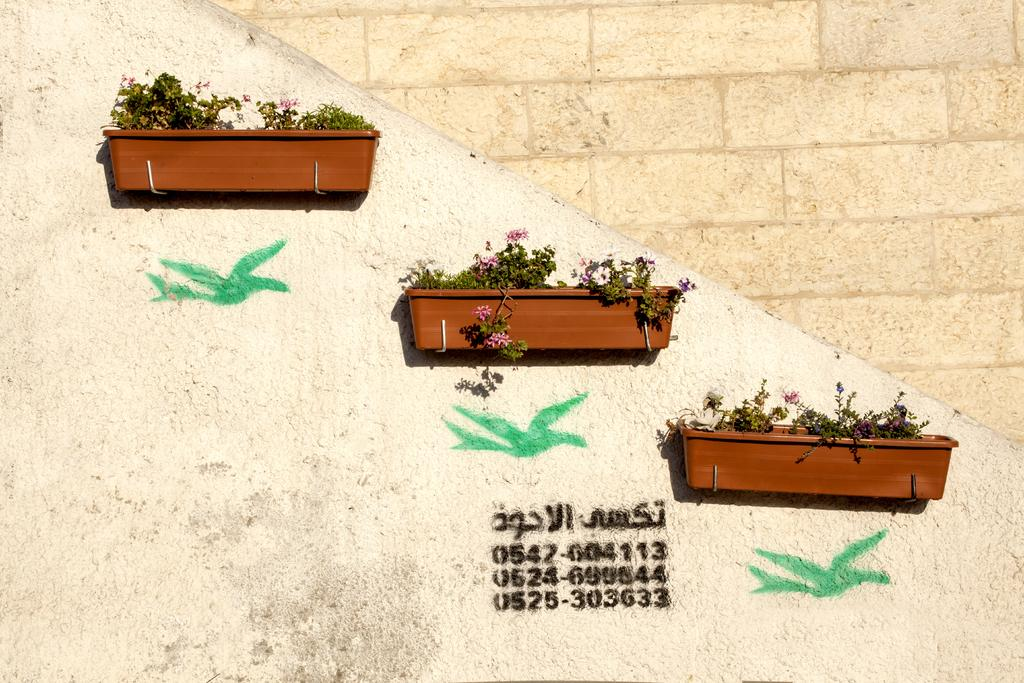What is attached to the wall in the middle of the image? There are three plant pots attached to the wall in the middle of the image. What can be seen written on the wall? There are numerical numbers and some text written on the wall. Can you tell me how many nests are visible in the image? There are no nests present in the image. What type of achievement is being celebrated in the image? There is no event or achievement being celebrated in the image; it only features plant pots, numerical numbers, and text on the wall. 